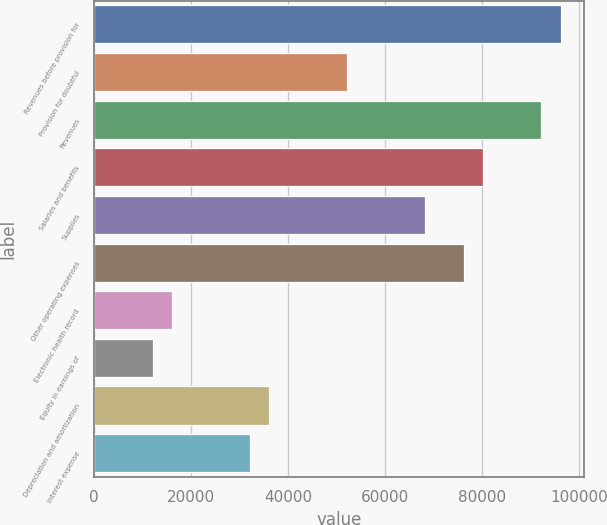Convert chart to OTSL. <chart><loc_0><loc_0><loc_500><loc_500><bar_chart><fcel>Revenues before provision for<fcel>Provision for doubtful<fcel>Revenues<fcel>Salaries and benefits<fcel>Supplies<fcel>Other operating expenses<fcel>Electronic health record<fcel>Equity in earnings of<fcel>Depreciation and amortization<fcel>Interest expense<nl><fcel>96202.9<fcel>52111.8<fcel>92194.6<fcel>80169.8<fcel>68144.9<fcel>76161.5<fcel>16037.3<fcel>12029<fcel>36078.7<fcel>32070.4<nl></chart> 